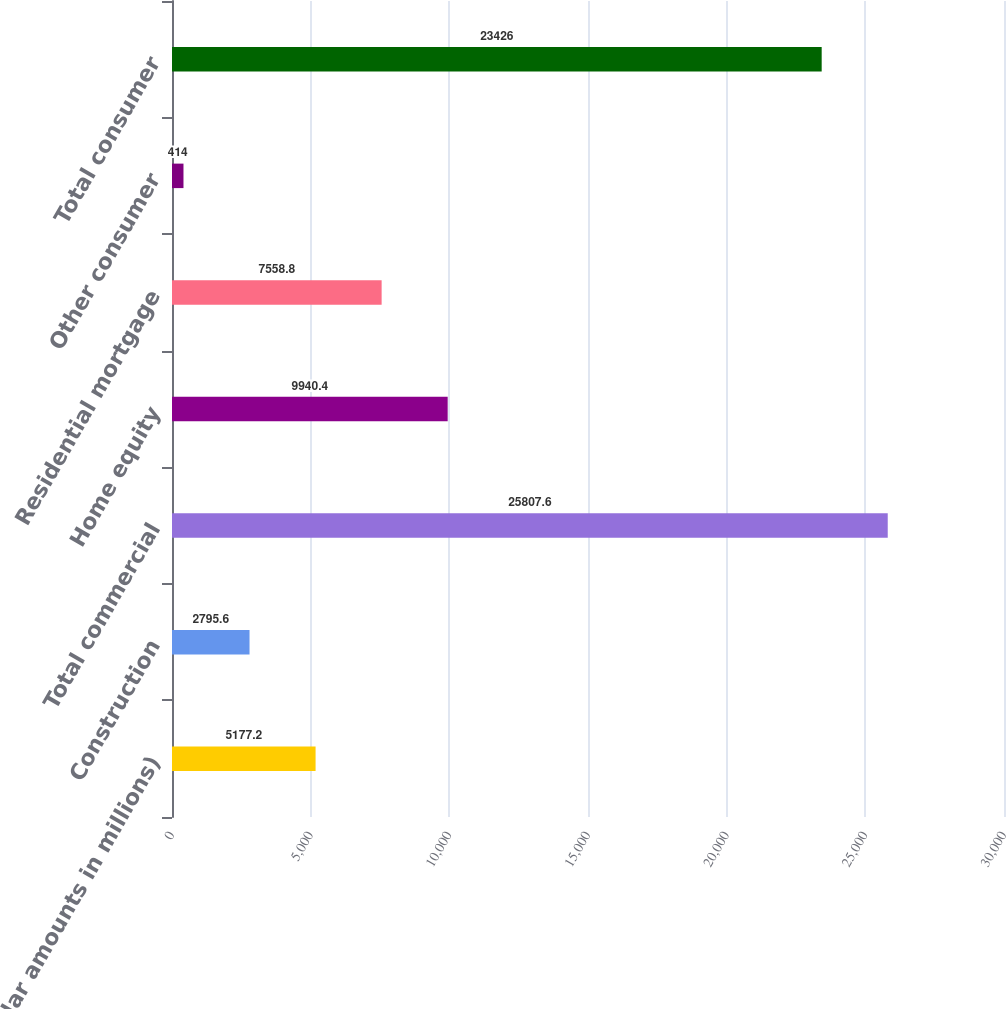Convert chart. <chart><loc_0><loc_0><loc_500><loc_500><bar_chart><fcel>(dollar amounts in millions)<fcel>Construction<fcel>Total commercial<fcel>Home equity<fcel>Residential mortgage<fcel>Other consumer<fcel>Total consumer<nl><fcel>5177.2<fcel>2795.6<fcel>25807.6<fcel>9940.4<fcel>7558.8<fcel>414<fcel>23426<nl></chart> 